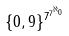<formula> <loc_0><loc_0><loc_500><loc_500>\{ 0 , 9 \} ^ { 7 ^ { 7 ^ { \aleph _ { 0 } } } }</formula> 